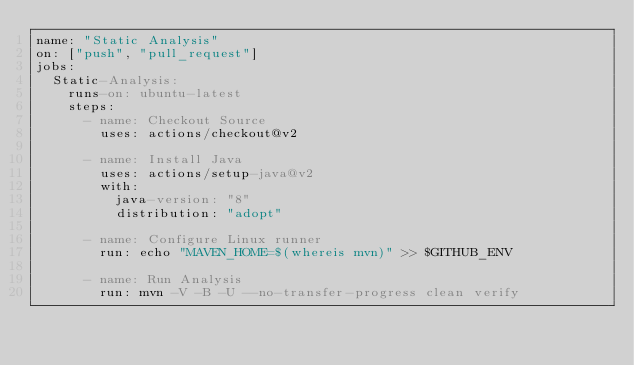<code> <loc_0><loc_0><loc_500><loc_500><_YAML_>name: "Static Analysis"
on: ["push", "pull_request"]
jobs:
  Static-Analysis:
    runs-on: ubuntu-latest
    steps:
      - name: Checkout Source
        uses: actions/checkout@v2

      - name: Install Java
        uses: actions/setup-java@v2
        with:
          java-version: "8"
          distribution: "adopt"

      - name: Configure Linux runner
        run: echo "MAVEN_HOME=$(whereis mvn)" >> $GITHUB_ENV

      - name: Run Analysis
        run: mvn -V -B -U --no-transfer-progress clean verify</code> 